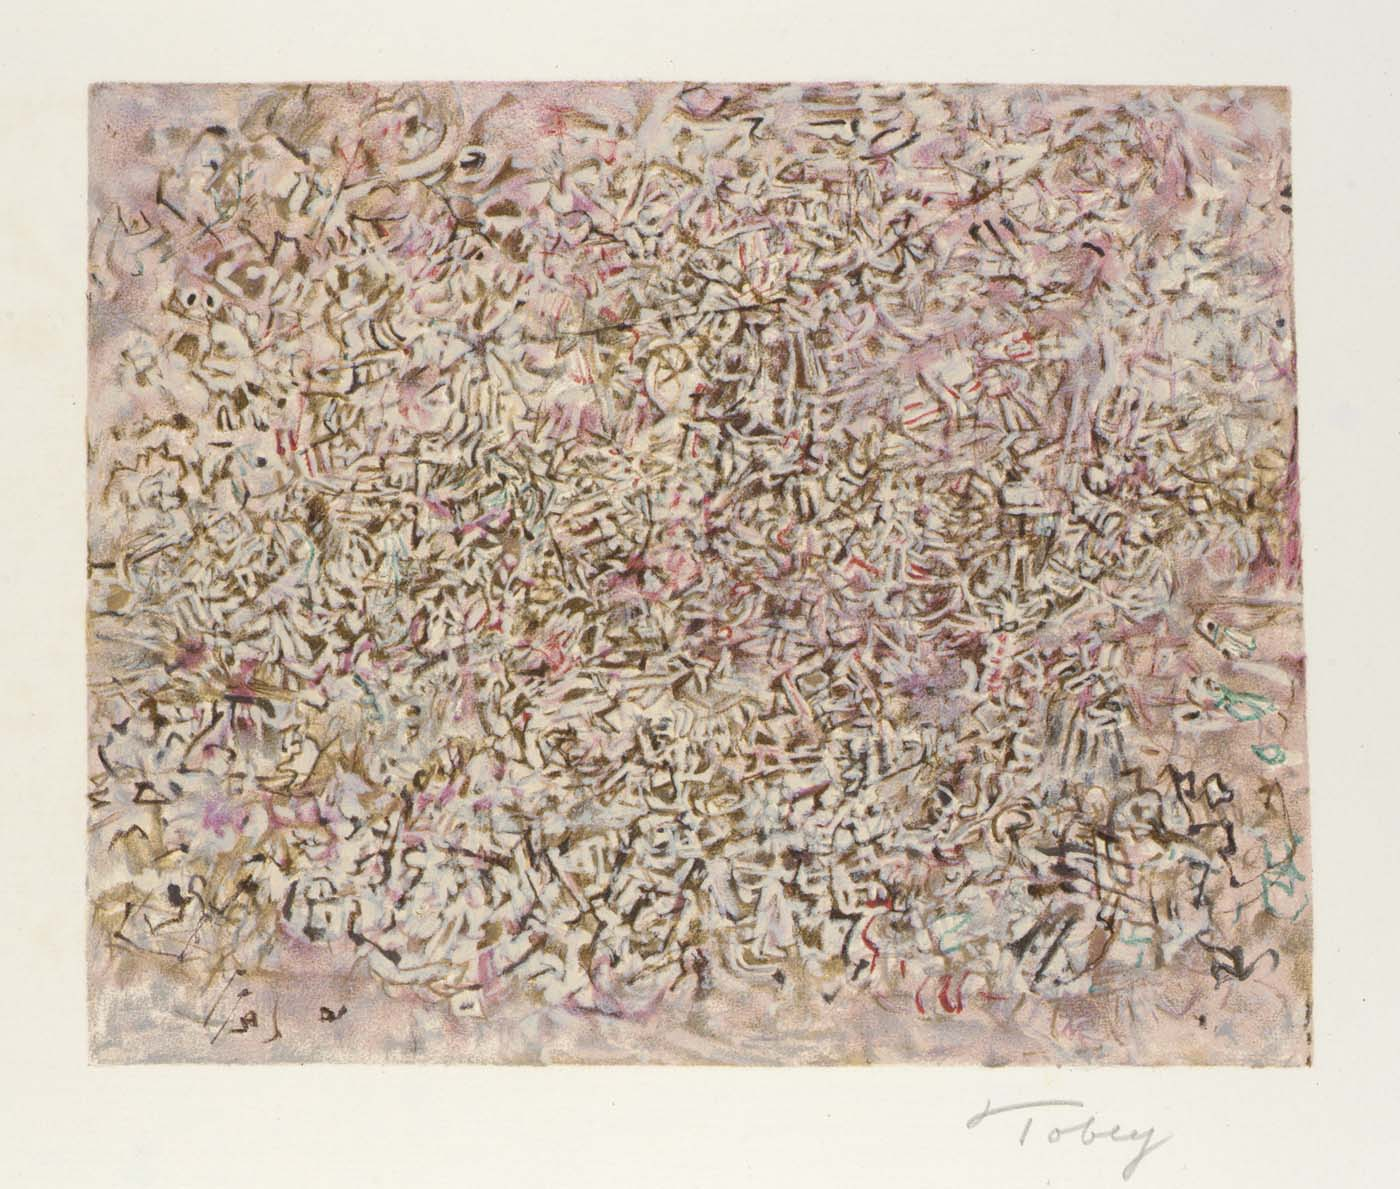Explain the visual content of the image in great detail. The image presents a captivating canvas rich in abstract expressionism, characterized by a complex interplay of lines, shapes, and colors. The canvas is dominated by earthy tones of pink and gray, punctuated by dashes of red, blue, and white which add a dynamic contrast. The composition is densely packed with abstract forms resembling scribbles, evoking a sense of chaos and spontaneity that invites the viewer to decipher its hidden narratives or emotions. The artwork, signed 'Toddy' on the bottom right, exemplifies a raw, unstructured form of artistic expression that seems to challenge traditional norms and evoke a personal, introspective reaction from its viewers. 